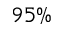<formula> <loc_0><loc_0><loc_500><loc_500>9 5 \%</formula> 